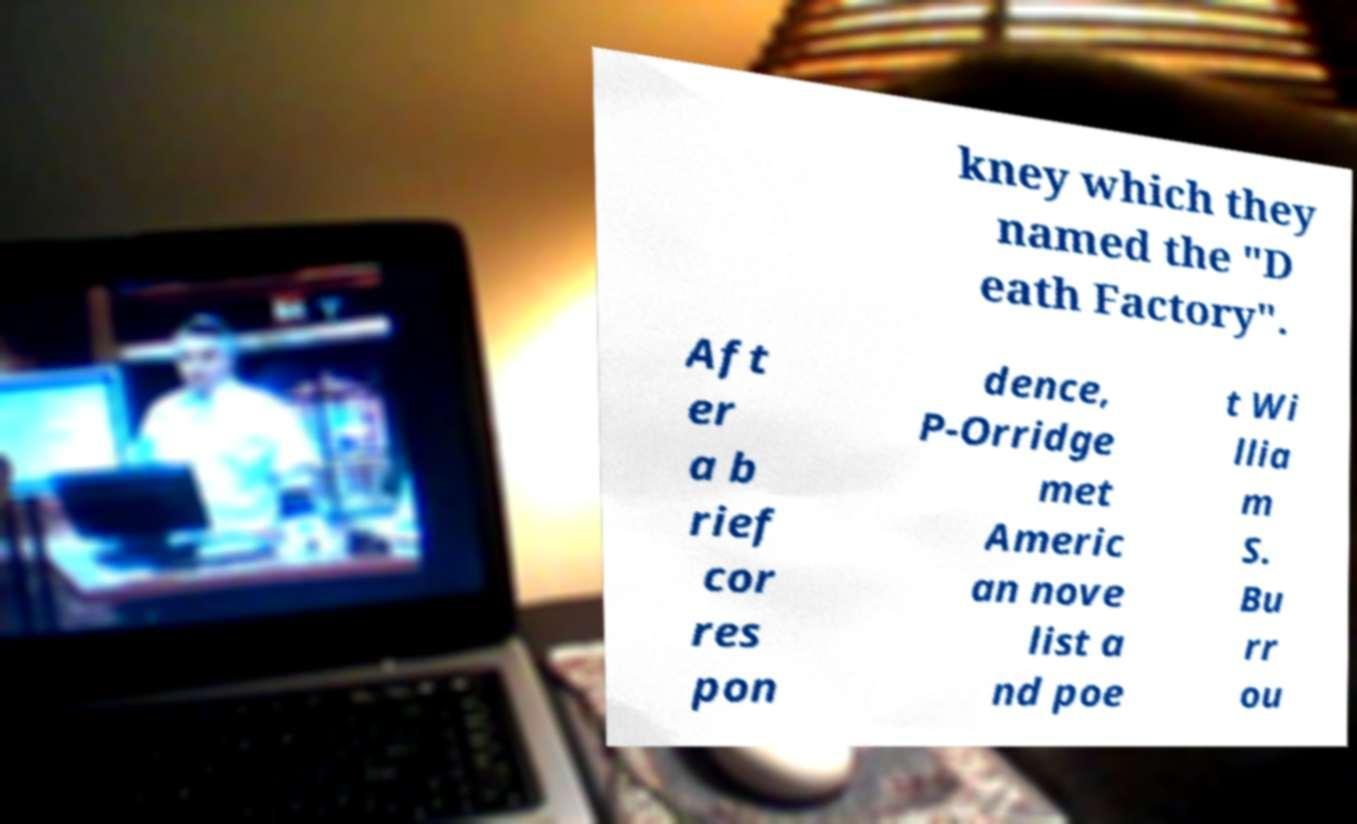Please read and relay the text visible in this image. What does it say? kney which they named the "D eath Factory". Aft er a b rief cor res pon dence, P-Orridge met Americ an nove list a nd poe t Wi llia m S. Bu rr ou 